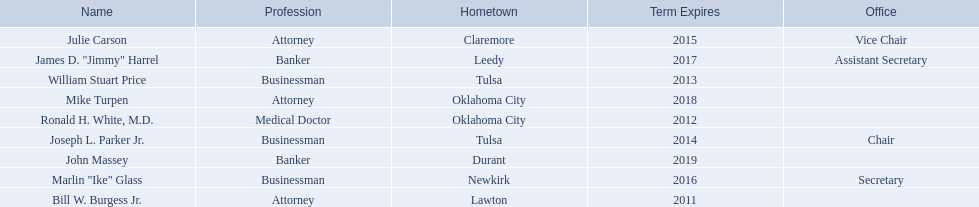Where is bill w. burgess jr. from? Lawton. Where is price and parker from? Tulsa. Who is from the same state as white? Mike Turpen. 